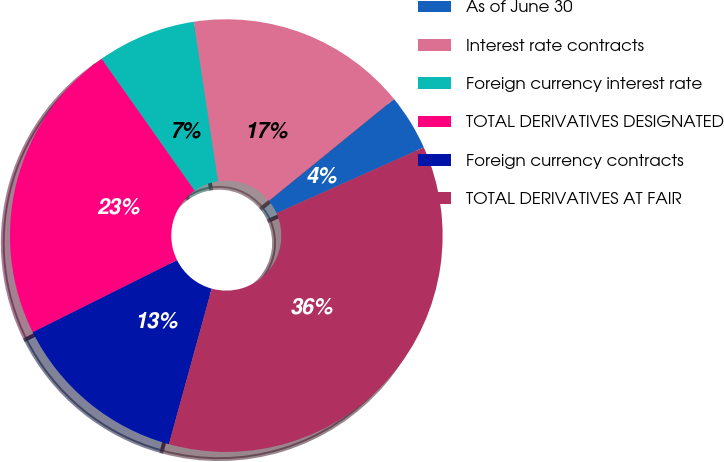Convert chart. <chart><loc_0><loc_0><loc_500><loc_500><pie_chart><fcel>As of June 30<fcel>Interest rate contracts<fcel>Foreign currency interest rate<fcel>TOTAL DERIVATIVES DESIGNATED<fcel>Foreign currency contracts<fcel>TOTAL DERIVATIVES AT FAIR<nl><fcel>4.19%<fcel>16.53%<fcel>7.37%<fcel>22.59%<fcel>13.36%<fcel>35.95%<nl></chart> 